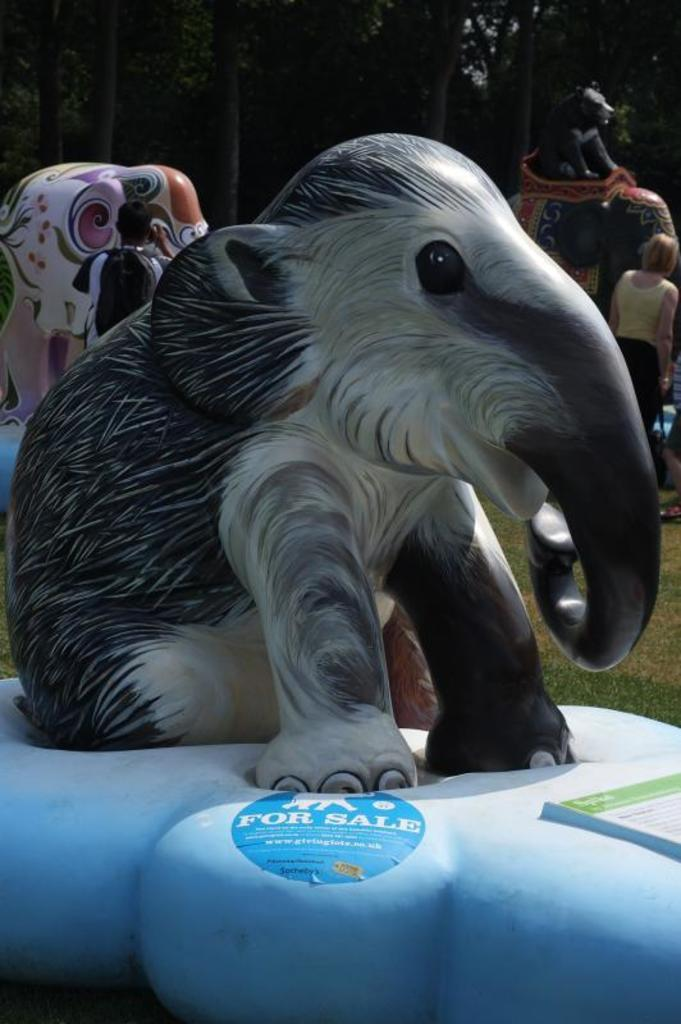What type of art is present in the image? There are sculptures in the image. What type of natural elements can be seen in the image? There are trees in the image. What are the persons in the image doing? The persons in the image are standing on the ground. What letter is being held by the sculpture in the image? There is no letter present in the image; it features sculptures and trees. How many children are visible in the image? There is no mention of children in the image; it features sculptures, trees, and persons standing on the ground. 